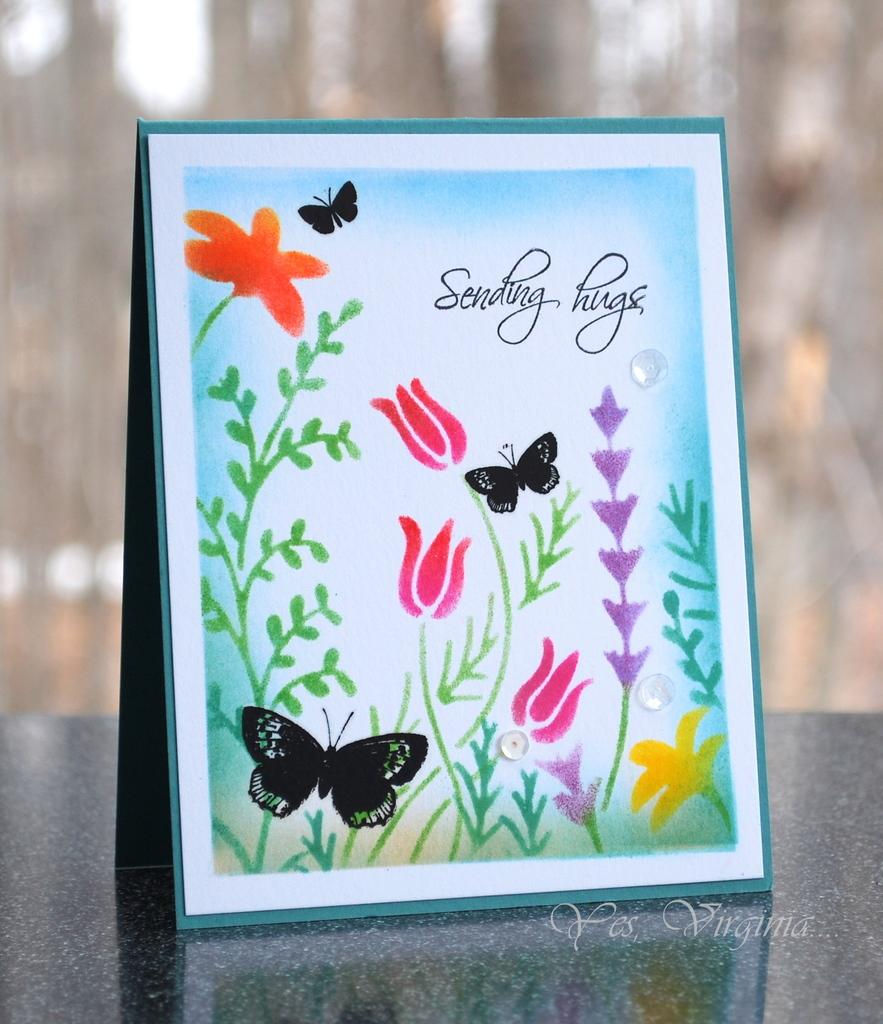What is featured on the poster in the picture? There is a poster with text and images in the picture. Can you describe the background of the image? The background of the image is blurred. Where is some text located in the picture? There is some text in the bottom right side of the picture. What type of hair can be seen on the ship in the image? There is no ship or hair present in the image. How much waste is visible in the image? There is no waste visible in the image. 